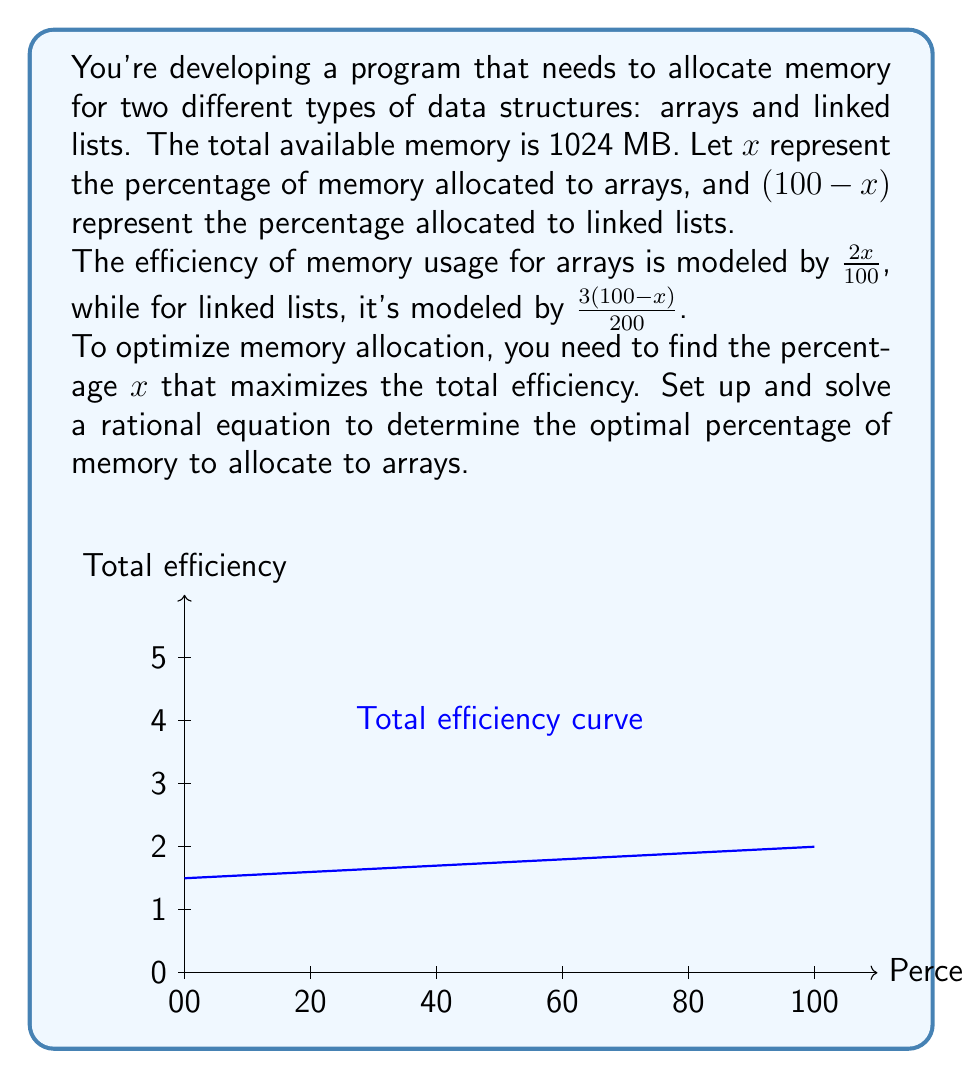What is the answer to this math problem? Let's approach this step-by-step:

1) The total efficiency (E) is the sum of the efficiencies for arrays and linked lists:

   $$E = \frac{2x}{100} + \frac{3(100-x)}{200}$$

2) To find the maximum efficiency, we need to find where the derivative of E with respect to x equals zero:

   $$\frac{dE}{dx} = \frac{2}{100} - \frac{3}{200} = 0$$

3) Simplify the equation:

   $$\frac{4}{100} - \frac{3}{200} = 0$$

4) Find a common denominator:

   $$\frac{8}{200} - \frac{3}{200} = 0$$

5) Combine like terms:

   $$\frac{5}{200} = 0$$

6) This is always true, which means our original function doesn't have a maximum or minimum point. Instead, it's a linear function.

7) To find which end of the range gives the maximum value, let's evaluate E at x = 0 and x = 100:

   At x = 0: $E = 0 + \frac{3(100)}{200} = 1.5$
   At x = 100: $E = \frac{2(100)}{100} + 0 = 2$

8) The maximum efficiency occurs when x = 100, meaning 100% of the memory should be allocated to arrays.
Answer: 100% to arrays 